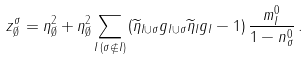Convert formula to latex. <formula><loc_0><loc_0><loc_500><loc_500>z _ { \emptyset } ^ { \sigma } = \eta _ { \emptyset } ^ { 2 } + \eta _ { \emptyset } ^ { 2 } \sum _ { I \, ( \sigma \not \in I ) } \left ( \widetilde { \eta } _ { I \cup \sigma } g _ { I \cup \sigma } \widetilde { \eta } _ { I } g _ { I } - 1 \right ) \frac { m _ { I } ^ { 0 } } { 1 - n _ { \sigma } ^ { 0 } } \, .</formula> 